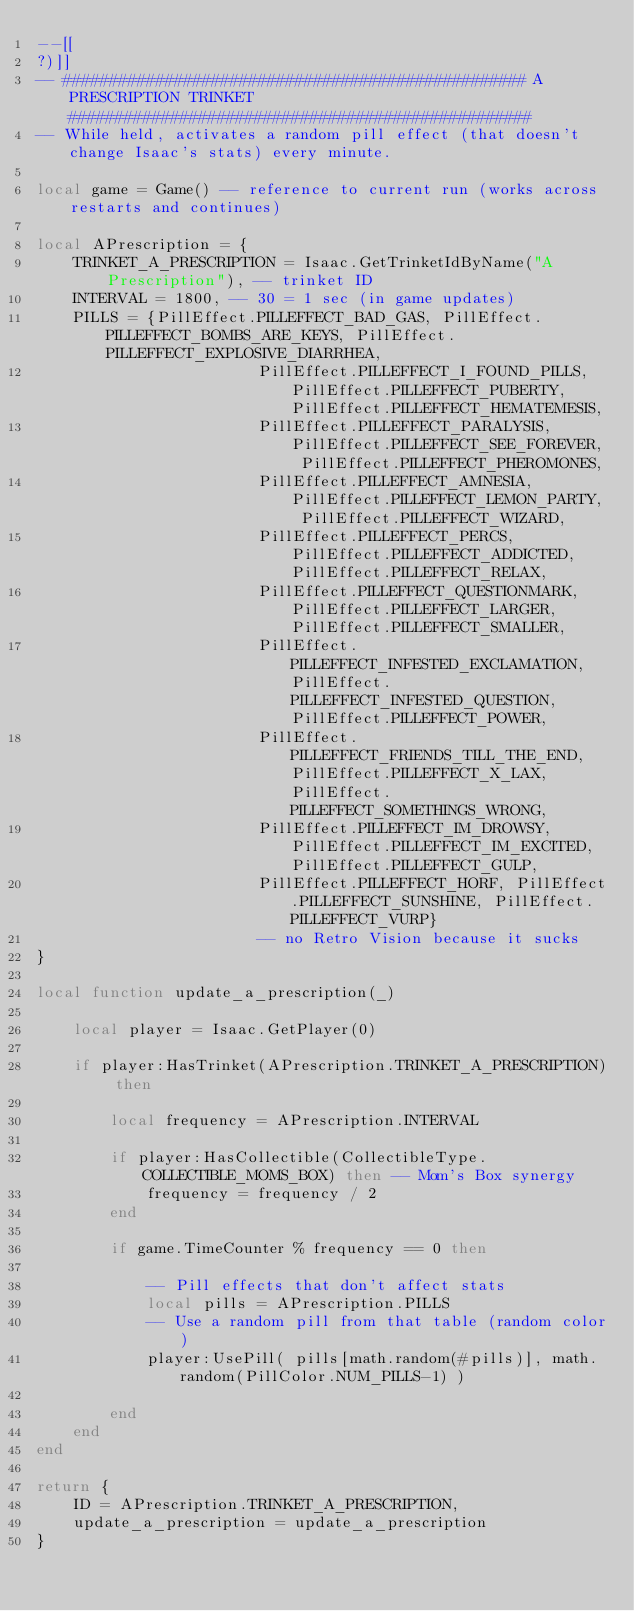Convert code to text. <code><loc_0><loc_0><loc_500><loc_500><_Lua_>--[[
?)]]
-- ################################################## A PRESCRIPTION TRINKET ##################################################
-- While held, activates a random pill effect (that doesn't change Isaac's stats) every minute.

local game = Game() -- reference to current run (works across restarts and continues)

local APrescription = {
	TRINKET_A_PRESCRIPTION = Isaac.GetTrinketIdByName("A Prescription"), -- trinket ID
	INTERVAL = 1800, -- 30 = 1 sec (in game updates)
	PILLS = {PillEffect.PILLEFFECT_BAD_GAS, PillEffect.PILLEFFECT_BOMBS_ARE_KEYS, PillEffect.PILLEFFECT_EXPLOSIVE_DIARRHEA,
						PillEffect.PILLEFFECT_I_FOUND_PILLS, PillEffect.PILLEFFECT_PUBERTY, PillEffect.PILLEFFECT_HEMATEMESIS,
						PillEffect.PILLEFFECT_PARALYSIS, PillEffect.PILLEFFECT_SEE_FOREVER, PillEffect.PILLEFFECT_PHEROMONES,
						PillEffect.PILLEFFECT_AMNESIA, PillEffect.PILLEFFECT_LEMON_PARTY, PillEffect.PILLEFFECT_WIZARD,
						PillEffect.PILLEFFECT_PERCS, PillEffect.PILLEFFECT_ADDICTED, PillEffect.PILLEFFECT_RELAX,
						PillEffect.PILLEFFECT_QUESTIONMARK, PillEffect.PILLEFFECT_LARGER, PillEffect.PILLEFFECT_SMALLER,
						PillEffect.PILLEFFECT_INFESTED_EXCLAMATION, PillEffect.PILLEFFECT_INFESTED_QUESTION, PillEffect.PILLEFFECT_POWER,
						PillEffect.PILLEFFECT_FRIENDS_TILL_THE_END, PillEffect.PILLEFFECT_X_LAX, PillEffect.PILLEFFECT_SOMETHINGS_WRONG,
						PillEffect.PILLEFFECT_IM_DROWSY, PillEffect.PILLEFFECT_IM_EXCITED, PillEffect.PILLEFFECT_GULP,
						PillEffect.PILLEFFECT_HORF, PillEffect.PILLEFFECT_SUNSHINE, PillEffect.PILLEFFECT_VURP}
						-- no Retro Vision because it sucks
}

local function update_a_prescription(_)

	local player = Isaac.GetPlayer(0)

	if player:HasTrinket(APrescription.TRINKET_A_PRESCRIPTION) then

		local frequency = APrescription.INTERVAL

		if player:HasCollectible(CollectibleType.COLLECTIBLE_MOMS_BOX) then -- Mom's Box synergy
			frequency = frequency / 2
		end

		if game.TimeCounter % frequency == 0 then

			-- Pill effects that don't affect stats
			local pills = APrescription.PILLS
			-- Use a random pill from that table (random color)
			player:UsePill( pills[math.random(#pills)], math.random(PillColor.NUM_PILLS-1) )

		end
	end
end

return {
	ID = APrescription.TRINKET_A_PRESCRIPTION,
	update_a_prescription = update_a_prescription
}</code> 